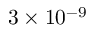Convert formula to latex. <formula><loc_0><loc_0><loc_500><loc_500>3 \times 1 0 ^ { - 9 } \</formula> 